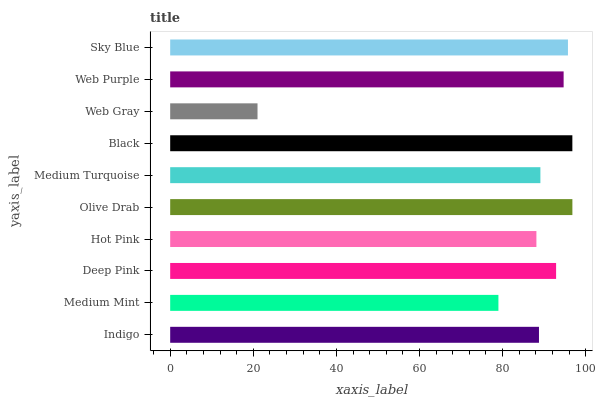Is Web Gray the minimum?
Answer yes or no. Yes. Is Olive Drab the maximum?
Answer yes or no. Yes. Is Medium Mint the minimum?
Answer yes or no. No. Is Medium Mint the maximum?
Answer yes or no. No. Is Indigo greater than Medium Mint?
Answer yes or no. Yes. Is Medium Mint less than Indigo?
Answer yes or no. Yes. Is Medium Mint greater than Indigo?
Answer yes or no. No. Is Indigo less than Medium Mint?
Answer yes or no. No. Is Deep Pink the high median?
Answer yes or no. Yes. Is Medium Turquoise the low median?
Answer yes or no. Yes. Is Sky Blue the high median?
Answer yes or no. No. Is Hot Pink the low median?
Answer yes or no. No. 